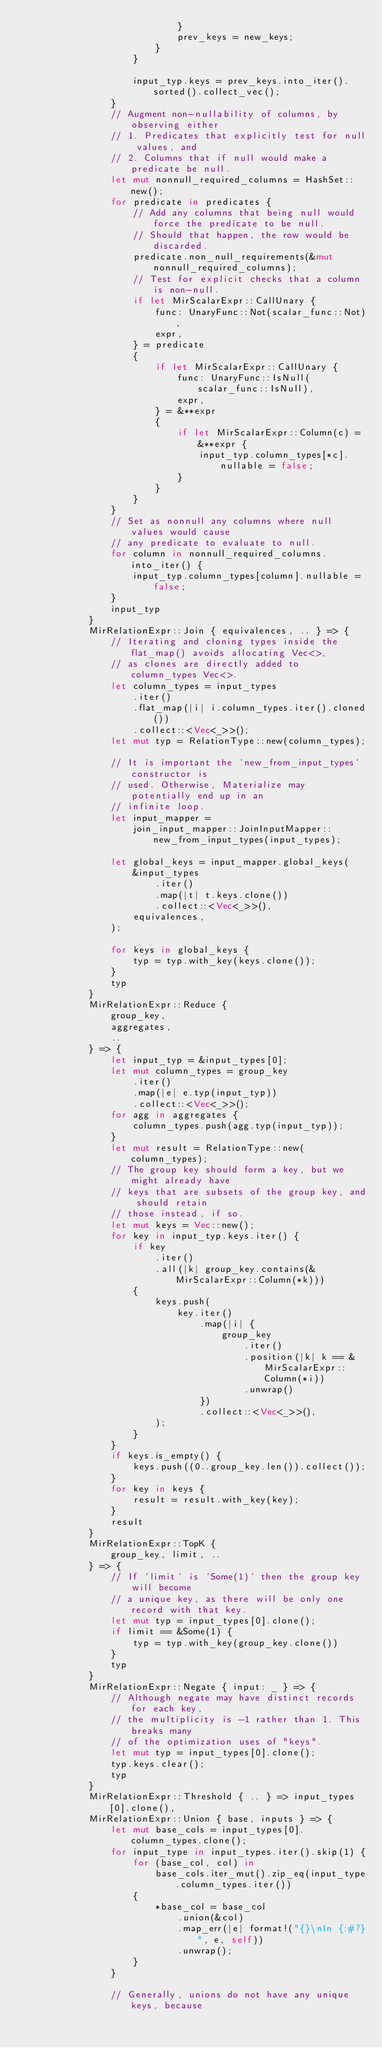<code> <loc_0><loc_0><loc_500><loc_500><_Rust_>                            }
                            prev_keys = new_keys;
                        }
                    }

                    input_typ.keys = prev_keys.into_iter().sorted().collect_vec();
                }
                // Augment non-nullability of columns, by observing either
                // 1. Predicates that explicitly test for null values, and
                // 2. Columns that if null would make a predicate be null.
                let mut nonnull_required_columns = HashSet::new();
                for predicate in predicates {
                    // Add any columns that being null would force the predicate to be null.
                    // Should that happen, the row would be discarded.
                    predicate.non_null_requirements(&mut nonnull_required_columns);
                    // Test for explicit checks that a column is non-null.
                    if let MirScalarExpr::CallUnary {
                        func: UnaryFunc::Not(scalar_func::Not),
                        expr,
                    } = predicate
                    {
                        if let MirScalarExpr::CallUnary {
                            func: UnaryFunc::IsNull(scalar_func::IsNull),
                            expr,
                        } = &**expr
                        {
                            if let MirScalarExpr::Column(c) = &**expr {
                                input_typ.column_types[*c].nullable = false;
                            }
                        }
                    }
                }
                // Set as nonnull any columns where null values would cause
                // any predicate to evaluate to null.
                for column in nonnull_required_columns.into_iter() {
                    input_typ.column_types[column].nullable = false;
                }
                input_typ
            }
            MirRelationExpr::Join { equivalences, .. } => {
                // Iterating and cloning types inside the flat_map() avoids allocating Vec<>,
                // as clones are directly added to column_types Vec<>.
                let column_types = input_types
                    .iter()
                    .flat_map(|i| i.column_types.iter().cloned())
                    .collect::<Vec<_>>();
                let mut typ = RelationType::new(column_types);

                // It is important the `new_from_input_types` constructor is
                // used. Otherwise, Materialize may potentially end up in an
                // infinite loop.
                let input_mapper =
                    join_input_mapper::JoinInputMapper::new_from_input_types(input_types);

                let global_keys = input_mapper.global_keys(
                    &input_types
                        .iter()
                        .map(|t| t.keys.clone())
                        .collect::<Vec<_>>(),
                    equivalences,
                );

                for keys in global_keys {
                    typ = typ.with_key(keys.clone());
                }
                typ
            }
            MirRelationExpr::Reduce {
                group_key,
                aggregates,
                ..
            } => {
                let input_typ = &input_types[0];
                let mut column_types = group_key
                    .iter()
                    .map(|e| e.typ(input_typ))
                    .collect::<Vec<_>>();
                for agg in aggregates {
                    column_types.push(agg.typ(input_typ));
                }
                let mut result = RelationType::new(column_types);
                // The group key should form a key, but we might already have
                // keys that are subsets of the group key, and should retain
                // those instead, if so.
                let mut keys = Vec::new();
                for key in input_typ.keys.iter() {
                    if key
                        .iter()
                        .all(|k| group_key.contains(&MirScalarExpr::Column(*k)))
                    {
                        keys.push(
                            key.iter()
                                .map(|i| {
                                    group_key
                                        .iter()
                                        .position(|k| k == &MirScalarExpr::Column(*i))
                                        .unwrap()
                                })
                                .collect::<Vec<_>>(),
                        );
                    }
                }
                if keys.is_empty() {
                    keys.push((0..group_key.len()).collect());
                }
                for key in keys {
                    result = result.with_key(key);
                }
                result
            }
            MirRelationExpr::TopK {
                group_key, limit, ..
            } => {
                // If `limit` is `Some(1)` then the group key will become
                // a unique key, as there will be only one record with that key.
                let mut typ = input_types[0].clone();
                if limit == &Some(1) {
                    typ = typ.with_key(group_key.clone())
                }
                typ
            }
            MirRelationExpr::Negate { input: _ } => {
                // Although negate may have distinct records for each key,
                // the multiplicity is -1 rather than 1. This breaks many
                // of the optimization uses of "keys".
                let mut typ = input_types[0].clone();
                typ.keys.clear();
                typ
            }
            MirRelationExpr::Threshold { .. } => input_types[0].clone(),
            MirRelationExpr::Union { base, inputs } => {
                let mut base_cols = input_types[0].column_types.clone();
                for input_type in input_types.iter().skip(1) {
                    for (base_col, col) in
                        base_cols.iter_mut().zip_eq(input_type.column_types.iter())
                    {
                        *base_col = base_col
                            .union(&col)
                            .map_err(|e| format!("{}\nIn {:#?}", e, self))
                            .unwrap();
                    }
                }

                // Generally, unions do not have any unique keys, because</code> 